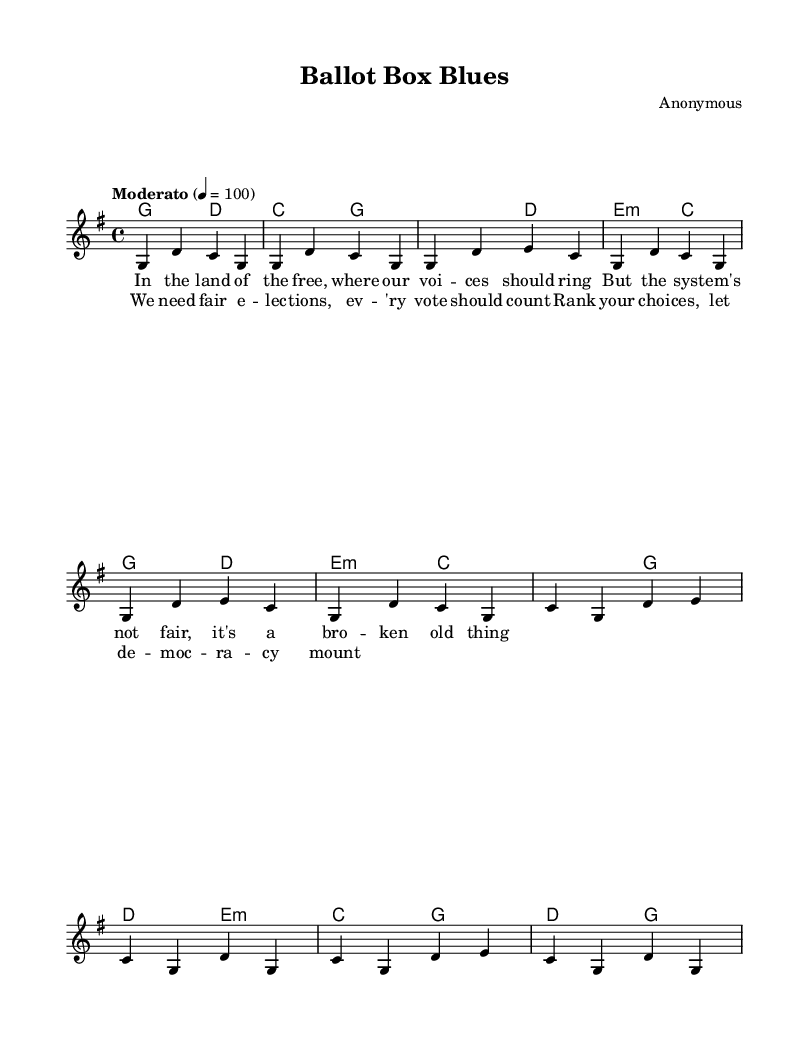What is the key signature of this music? The key signature is indicated at the beginning of the staff and is G major, which contains one sharp (F#).
Answer: G major What is the time signature of this music? The time signature is presented just after the key signature and is 4/4, indicating four beats per measure.
Answer: 4/4 What is the tempo marking for this piece? The tempo indication "Moderato" is shown above the music, suggesting a moderate speed. The metronome marking of 4 = 100 further specifies the beats per minute.
Answer: Moderato, 4 = 100 How many measures are in the verse section? By counting the measures in the verse portion of the sheet music, there are a total of 4 measures indicated in the melody line.
Answer: 4 What musical form does the song follow? The structure includes an introduction, a verse, and a chorus, following the common folk song format of alternating verse and chorus.
Answer: Verse-Chorus structure What are the primary themes of the lyrics? The lyrics reflect themes of voting rights and the need for fair elections, central to the protest ballad genre, emphasizing democracy and equal representation.
Answer: Voting rights and democracy Which chords are used in the chorus? The chords in the chorus section are shown in the harmonies line, and they include C, G, D, and E minor.
Answer: C, G, D, E minor 